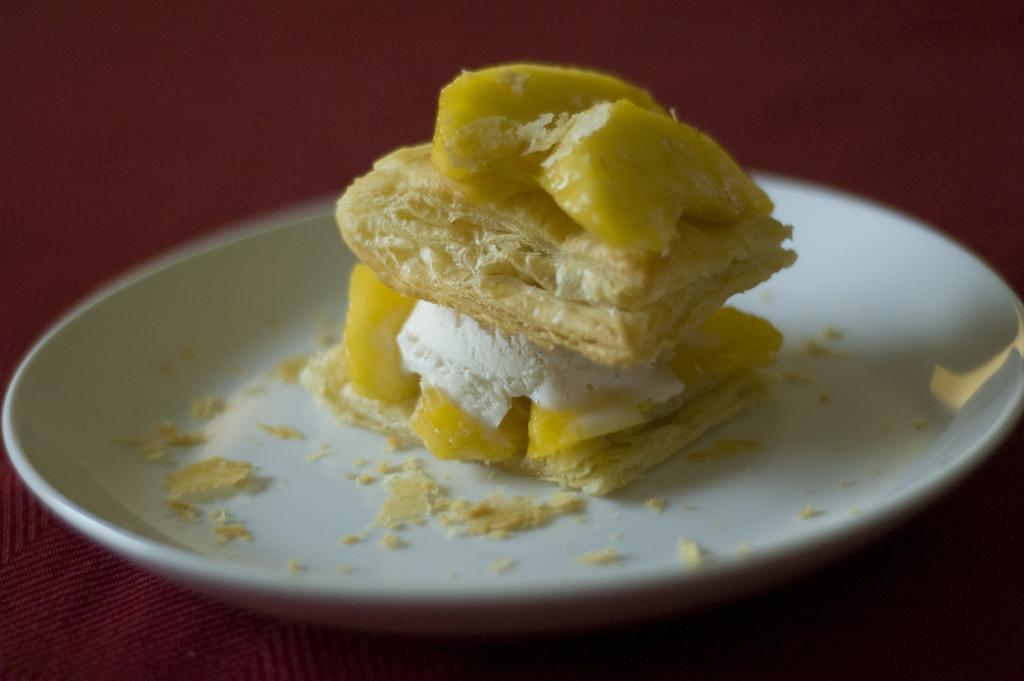What type of landscape is depicted in the image? There is a desert in the image. What is unique about this desert? The desert is made with baked food. What other ingredients are included in the desert? Fruits are included in the desert. What is served on a plate alongside the desert? Cream is served on a plate with the desert. Where is the pump located in the image? There is no pump present in the image. What activity is taking place during the recess in the image? There is no recess or any activity taking place in the image; it features a desert made with baked food. 